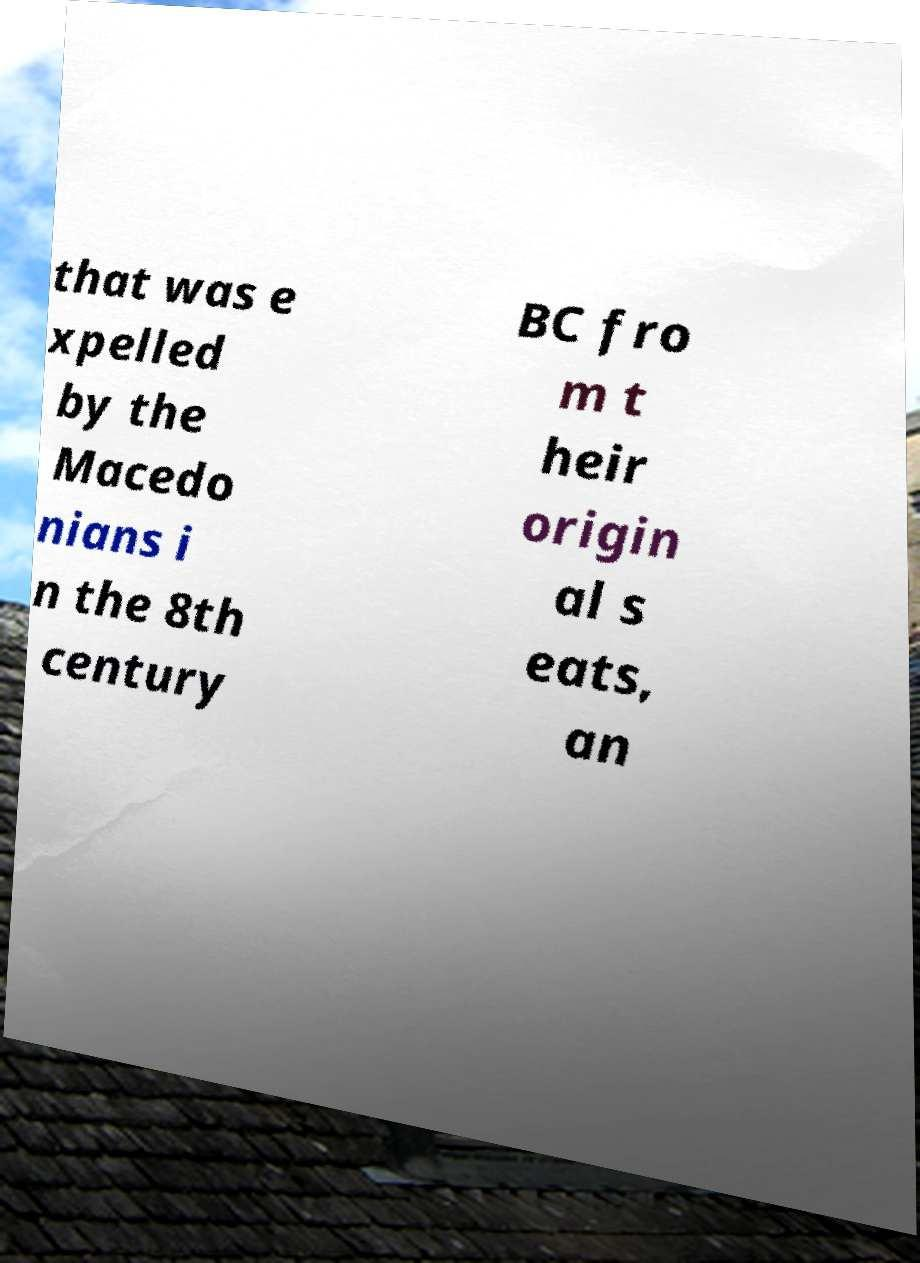I need the written content from this picture converted into text. Can you do that? that was e xpelled by the Macedo nians i n the 8th century BC fro m t heir origin al s eats, an 